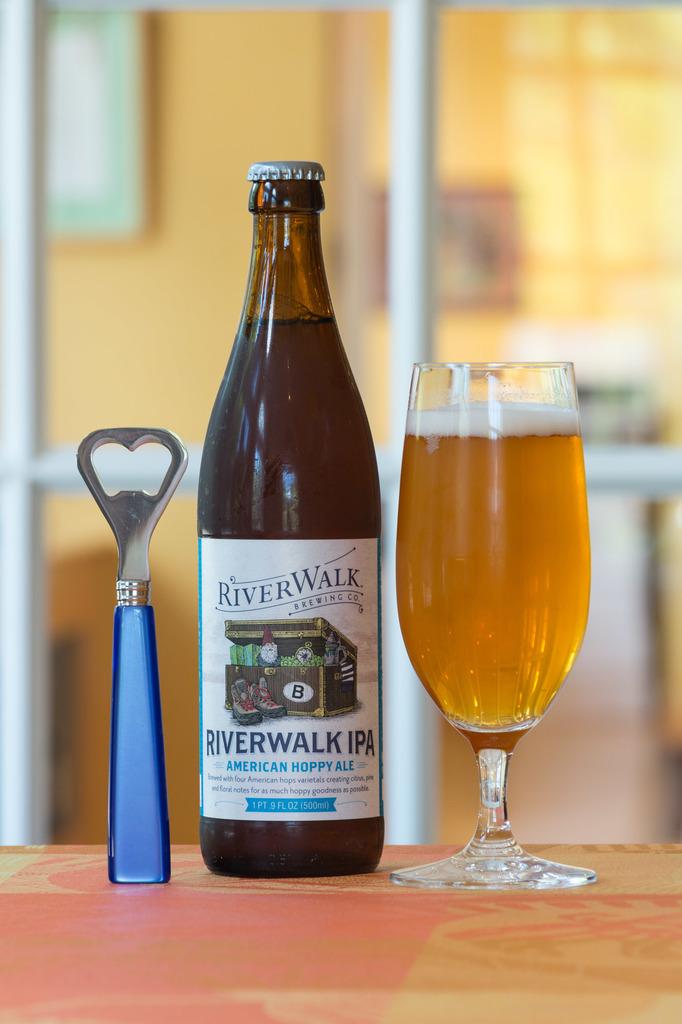What country has hoppy ale?
Make the answer very short. America. How many ml in this beer bottle?
Ensure brevity in your answer.  500. 